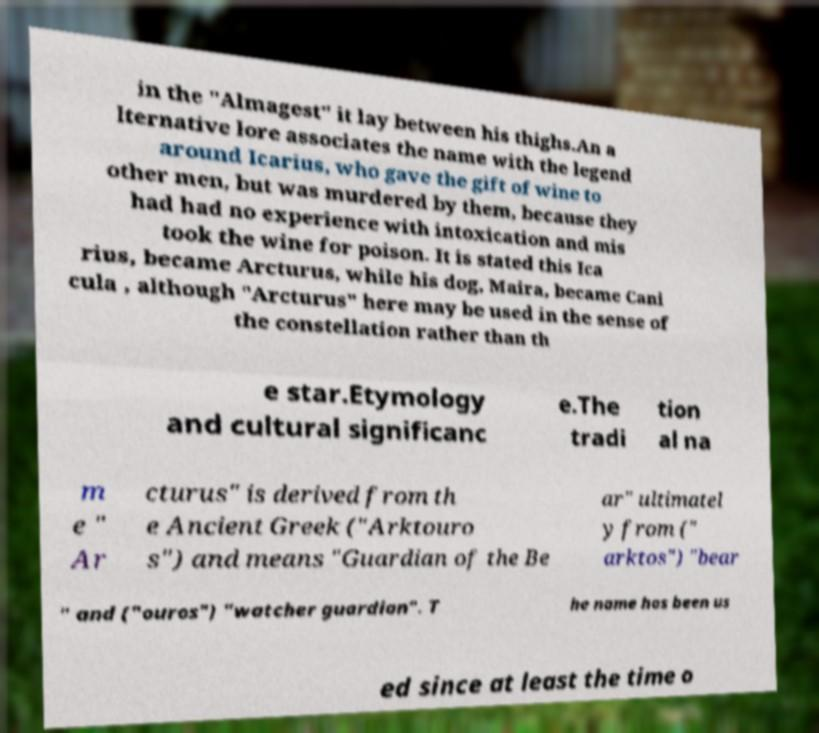Could you assist in decoding the text presented in this image and type it out clearly? in the "Almagest" it lay between his thighs.An a lternative lore associates the name with the legend around Icarius, who gave the gift of wine to other men, but was murdered by them, because they had had no experience with intoxication and mis took the wine for poison. It is stated this Ica rius, became Arcturus, while his dog, Maira, became Cani cula , although "Arcturus" here may be used in the sense of the constellation rather than th e star.Etymology and cultural significanc e.The tradi tion al na m e " Ar cturus" is derived from th e Ancient Greek ("Arktouro s") and means "Guardian of the Be ar" ultimatel y from (" arktos") "bear " and ("ouros") "watcher guardian". T he name has been us ed since at least the time o 